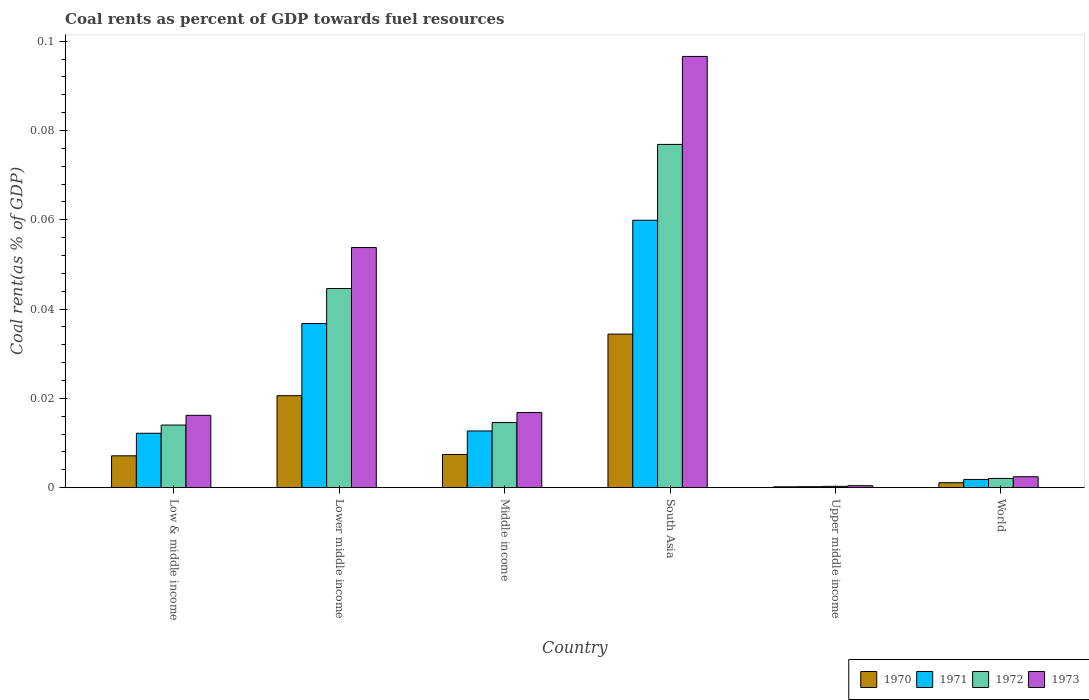How many groups of bars are there?
Give a very brief answer. 6. Are the number of bars per tick equal to the number of legend labels?
Your response must be concise. Yes. In how many cases, is the number of bars for a given country not equal to the number of legend labels?
Offer a terse response. 0. What is the coal rent in 1972 in Lower middle income?
Keep it short and to the point. 0.04. Across all countries, what is the maximum coal rent in 1971?
Your answer should be very brief. 0.06. Across all countries, what is the minimum coal rent in 1970?
Provide a succinct answer. 0. In which country was the coal rent in 1970 maximum?
Your answer should be compact. South Asia. In which country was the coal rent in 1970 minimum?
Your response must be concise. Upper middle income. What is the total coal rent in 1971 in the graph?
Provide a short and direct response. 0.12. What is the difference between the coal rent in 1971 in Low & middle income and that in Lower middle income?
Give a very brief answer. -0.02. What is the difference between the coal rent in 1971 in Upper middle income and the coal rent in 1972 in Middle income?
Offer a terse response. -0.01. What is the average coal rent in 1971 per country?
Provide a short and direct response. 0.02. What is the difference between the coal rent of/in 1972 and coal rent of/in 1970 in World?
Your answer should be very brief. 0. In how many countries, is the coal rent in 1970 greater than 0.028 %?
Keep it short and to the point. 1. What is the ratio of the coal rent in 1970 in Middle income to that in World?
Your answer should be very brief. 6.74. Is the difference between the coal rent in 1972 in South Asia and Upper middle income greater than the difference between the coal rent in 1970 in South Asia and Upper middle income?
Provide a short and direct response. Yes. What is the difference between the highest and the second highest coal rent in 1971?
Your answer should be compact. 0.05. What is the difference between the highest and the lowest coal rent in 1970?
Your answer should be very brief. 0.03. Is it the case that in every country, the sum of the coal rent in 1973 and coal rent in 1972 is greater than the sum of coal rent in 1970 and coal rent in 1971?
Make the answer very short. No. Are all the bars in the graph horizontal?
Offer a very short reply. No. How many countries are there in the graph?
Keep it short and to the point. 6. Are the values on the major ticks of Y-axis written in scientific E-notation?
Provide a succinct answer. No. Does the graph contain any zero values?
Your answer should be compact. No. Does the graph contain grids?
Ensure brevity in your answer.  No. Where does the legend appear in the graph?
Your answer should be very brief. Bottom right. How many legend labels are there?
Make the answer very short. 4. What is the title of the graph?
Your answer should be very brief. Coal rents as percent of GDP towards fuel resources. What is the label or title of the Y-axis?
Provide a short and direct response. Coal rent(as % of GDP). What is the Coal rent(as % of GDP) in 1970 in Low & middle income?
Give a very brief answer. 0.01. What is the Coal rent(as % of GDP) in 1971 in Low & middle income?
Your answer should be very brief. 0.01. What is the Coal rent(as % of GDP) in 1972 in Low & middle income?
Your answer should be compact. 0.01. What is the Coal rent(as % of GDP) of 1973 in Low & middle income?
Make the answer very short. 0.02. What is the Coal rent(as % of GDP) of 1970 in Lower middle income?
Provide a short and direct response. 0.02. What is the Coal rent(as % of GDP) in 1971 in Lower middle income?
Provide a short and direct response. 0.04. What is the Coal rent(as % of GDP) in 1972 in Lower middle income?
Your response must be concise. 0.04. What is the Coal rent(as % of GDP) in 1973 in Lower middle income?
Your response must be concise. 0.05. What is the Coal rent(as % of GDP) of 1970 in Middle income?
Keep it short and to the point. 0.01. What is the Coal rent(as % of GDP) of 1971 in Middle income?
Provide a succinct answer. 0.01. What is the Coal rent(as % of GDP) of 1972 in Middle income?
Provide a short and direct response. 0.01. What is the Coal rent(as % of GDP) in 1973 in Middle income?
Your answer should be compact. 0.02. What is the Coal rent(as % of GDP) in 1970 in South Asia?
Your response must be concise. 0.03. What is the Coal rent(as % of GDP) of 1971 in South Asia?
Your response must be concise. 0.06. What is the Coal rent(as % of GDP) in 1972 in South Asia?
Keep it short and to the point. 0.08. What is the Coal rent(as % of GDP) of 1973 in South Asia?
Offer a terse response. 0.1. What is the Coal rent(as % of GDP) in 1970 in Upper middle income?
Provide a short and direct response. 0. What is the Coal rent(as % of GDP) in 1971 in Upper middle income?
Keep it short and to the point. 0. What is the Coal rent(as % of GDP) in 1972 in Upper middle income?
Offer a very short reply. 0. What is the Coal rent(as % of GDP) in 1973 in Upper middle income?
Provide a succinct answer. 0. What is the Coal rent(as % of GDP) of 1970 in World?
Offer a very short reply. 0. What is the Coal rent(as % of GDP) of 1971 in World?
Your response must be concise. 0. What is the Coal rent(as % of GDP) of 1972 in World?
Make the answer very short. 0. What is the Coal rent(as % of GDP) of 1973 in World?
Your response must be concise. 0. Across all countries, what is the maximum Coal rent(as % of GDP) of 1970?
Keep it short and to the point. 0.03. Across all countries, what is the maximum Coal rent(as % of GDP) in 1971?
Provide a succinct answer. 0.06. Across all countries, what is the maximum Coal rent(as % of GDP) in 1972?
Provide a succinct answer. 0.08. Across all countries, what is the maximum Coal rent(as % of GDP) of 1973?
Your answer should be very brief. 0.1. Across all countries, what is the minimum Coal rent(as % of GDP) in 1970?
Provide a short and direct response. 0. Across all countries, what is the minimum Coal rent(as % of GDP) in 1971?
Ensure brevity in your answer.  0. Across all countries, what is the minimum Coal rent(as % of GDP) of 1972?
Your response must be concise. 0. Across all countries, what is the minimum Coal rent(as % of GDP) of 1973?
Keep it short and to the point. 0. What is the total Coal rent(as % of GDP) of 1970 in the graph?
Provide a short and direct response. 0.07. What is the total Coal rent(as % of GDP) of 1971 in the graph?
Make the answer very short. 0.12. What is the total Coal rent(as % of GDP) of 1972 in the graph?
Offer a very short reply. 0.15. What is the total Coal rent(as % of GDP) of 1973 in the graph?
Provide a succinct answer. 0.19. What is the difference between the Coal rent(as % of GDP) of 1970 in Low & middle income and that in Lower middle income?
Ensure brevity in your answer.  -0.01. What is the difference between the Coal rent(as % of GDP) of 1971 in Low & middle income and that in Lower middle income?
Your answer should be compact. -0.02. What is the difference between the Coal rent(as % of GDP) in 1972 in Low & middle income and that in Lower middle income?
Make the answer very short. -0.03. What is the difference between the Coal rent(as % of GDP) in 1973 in Low & middle income and that in Lower middle income?
Provide a succinct answer. -0.04. What is the difference between the Coal rent(as % of GDP) of 1970 in Low & middle income and that in Middle income?
Offer a very short reply. -0. What is the difference between the Coal rent(as % of GDP) of 1971 in Low & middle income and that in Middle income?
Your response must be concise. -0. What is the difference between the Coal rent(as % of GDP) of 1972 in Low & middle income and that in Middle income?
Offer a very short reply. -0. What is the difference between the Coal rent(as % of GDP) in 1973 in Low & middle income and that in Middle income?
Provide a short and direct response. -0. What is the difference between the Coal rent(as % of GDP) of 1970 in Low & middle income and that in South Asia?
Provide a succinct answer. -0.03. What is the difference between the Coal rent(as % of GDP) in 1971 in Low & middle income and that in South Asia?
Ensure brevity in your answer.  -0.05. What is the difference between the Coal rent(as % of GDP) in 1972 in Low & middle income and that in South Asia?
Keep it short and to the point. -0.06. What is the difference between the Coal rent(as % of GDP) of 1973 in Low & middle income and that in South Asia?
Provide a short and direct response. -0.08. What is the difference between the Coal rent(as % of GDP) of 1970 in Low & middle income and that in Upper middle income?
Provide a succinct answer. 0.01. What is the difference between the Coal rent(as % of GDP) in 1971 in Low & middle income and that in Upper middle income?
Provide a short and direct response. 0.01. What is the difference between the Coal rent(as % of GDP) of 1972 in Low & middle income and that in Upper middle income?
Provide a succinct answer. 0.01. What is the difference between the Coal rent(as % of GDP) in 1973 in Low & middle income and that in Upper middle income?
Your response must be concise. 0.02. What is the difference between the Coal rent(as % of GDP) in 1970 in Low & middle income and that in World?
Make the answer very short. 0.01. What is the difference between the Coal rent(as % of GDP) of 1971 in Low & middle income and that in World?
Make the answer very short. 0.01. What is the difference between the Coal rent(as % of GDP) of 1972 in Low & middle income and that in World?
Make the answer very short. 0.01. What is the difference between the Coal rent(as % of GDP) in 1973 in Low & middle income and that in World?
Make the answer very short. 0.01. What is the difference between the Coal rent(as % of GDP) of 1970 in Lower middle income and that in Middle income?
Keep it short and to the point. 0.01. What is the difference between the Coal rent(as % of GDP) of 1971 in Lower middle income and that in Middle income?
Provide a short and direct response. 0.02. What is the difference between the Coal rent(as % of GDP) in 1972 in Lower middle income and that in Middle income?
Keep it short and to the point. 0.03. What is the difference between the Coal rent(as % of GDP) in 1973 in Lower middle income and that in Middle income?
Your response must be concise. 0.04. What is the difference between the Coal rent(as % of GDP) in 1970 in Lower middle income and that in South Asia?
Offer a terse response. -0.01. What is the difference between the Coal rent(as % of GDP) of 1971 in Lower middle income and that in South Asia?
Ensure brevity in your answer.  -0.02. What is the difference between the Coal rent(as % of GDP) in 1972 in Lower middle income and that in South Asia?
Keep it short and to the point. -0.03. What is the difference between the Coal rent(as % of GDP) of 1973 in Lower middle income and that in South Asia?
Provide a short and direct response. -0.04. What is the difference between the Coal rent(as % of GDP) of 1970 in Lower middle income and that in Upper middle income?
Provide a succinct answer. 0.02. What is the difference between the Coal rent(as % of GDP) of 1971 in Lower middle income and that in Upper middle income?
Your response must be concise. 0.04. What is the difference between the Coal rent(as % of GDP) in 1972 in Lower middle income and that in Upper middle income?
Provide a short and direct response. 0.04. What is the difference between the Coal rent(as % of GDP) of 1973 in Lower middle income and that in Upper middle income?
Offer a terse response. 0.05. What is the difference between the Coal rent(as % of GDP) of 1970 in Lower middle income and that in World?
Provide a succinct answer. 0.02. What is the difference between the Coal rent(as % of GDP) in 1971 in Lower middle income and that in World?
Provide a short and direct response. 0.03. What is the difference between the Coal rent(as % of GDP) of 1972 in Lower middle income and that in World?
Your answer should be compact. 0.04. What is the difference between the Coal rent(as % of GDP) of 1973 in Lower middle income and that in World?
Provide a short and direct response. 0.05. What is the difference between the Coal rent(as % of GDP) in 1970 in Middle income and that in South Asia?
Offer a very short reply. -0.03. What is the difference between the Coal rent(as % of GDP) in 1971 in Middle income and that in South Asia?
Keep it short and to the point. -0.05. What is the difference between the Coal rent(as % of GDP) of 1972 in Middle income and that in South Asia?
Provide a short and direct response. -0.06. What is the difference between the Coal rent(as % of GDP) in 1973 in Middle income and that in South Asia?
Make the answer very short. -0.08. What is the difference between the Coal rent(as % of GDP) of 1970 in Middle income and that in Upper middle income?
Make the answer very short. 0.01. What is the difference between the Coal rent(as % of GDP) of 1971 in Middle income and that in Upper middle income?
Give a very brief answer. 0.01. What is the difference between the Coal rent(as % of GDP) of 1972 in Middle income and that in Upper middle income?
Keep it short and to the point. 0.01. What is the difference between the Coal rent(as % of GDP) of 1973 in Middle income and that in Upper middle income?
Offer a terse response. 0.02. What is the difference between the Coal rent(as % of GDP) of 1970 in Middle income and that in World?
Give a very brief answer. 0.01. What is the difference between the Coal rent(as % of GDP) in 1971 in Middle income and that in World?
Make the answer very short. 0.01. What is the difference between the Coal rent(as % of GDP) of 1972 in Middle income and that in World?
Provide a succinct answer. 0.01. What is the difference between the Coal rent(as % of GDP) in 1973 in Middle income and that in World?
Your answer should be compact. 0.01. What is the difference between the Coal rent(as % of GDP) in 1970 in South Asia and that in Upper middle income?
Your answer should be compact. 0.03. What is the difference between the Coal rent(as % of GDP) of 1971 in South Asia and that in Upper middle income?
Keep it short and to the point. 0.06. What is the difference between the Coal rent(as % of GDP) of 1972 in South Asia and that in Upper middle income?
Your answer should be compact. 0.08. What is the difference between the Coal rent(as % of GDP) of 1973 in South Asia and that in Upper middle income?
Provide a succinct answer. 0.1. What is the difference between the Coal rent(as % of GDP) in 1971 in South Asia and that in World?
Make the answer very short. 0.06. What is the difference between the Coal rent(as % of GDP) of 1972 in South Asia and that in World?
Keep it short and to the point. 0.07. What is the difference between the Coal rent(as % of GDP) of 1973 in South Asia and that in World?
Keep it short and to the point. 0.09. What is the difference between the Coal rent(as % of GDP) in 1970 in Upper middle income and that in World?
Offer a terse response. -0. What is the difference between the Coal rent(as % of GDP) of 1971 in Upper middle income and that in World?
Provide a short and direct response. -0. What is the difference between the Coal rent(as % of GDP) in 1972 in Upper middle income and that in World?
Keep it short and to the point. -0. What is the difference between the Coal rent(as % of GDP) of 1973 in Upper middle income and that in World?
Keep it short and to the point. -0. What is the difference between the Coal rent(as % of GDP) in 1970 in Low & middle income and the Coal rent(as % of GDP) in 1971 in Lower middle income?
Keep it short and to the point. -0.03. What is the difference between the Coal rent(as % of GDP) of 1970 in Low & middle income and the Coal rent(as % of GDP) of 1972 in Lower middle income?
Your answer should be very brief. -0.04. What is the difference between the Coal rent(as % of GDP) in 1970 in Low & middle income and the Coal rent(as % of GDP) in 1973 in Lower middle income?
Give a very brief answer. -0.05. What is the difference between the Coal rent(as % of GDP) of 1971 in Low & middle income and the Coal rent(as % of GDP) of 1972 in Lower middle income?
Give a very brief answer. -0.03. What is the difference between the Coal rent(as % of GDP) in 1971 in Low & middle income and the Coal rent(as % of GDP) in 1973 in Lower middle income?
Your response must be concise. -0.04. What is the difference between the Coal rent(as % of GDP) of 1972 in Low & middle income and the Coal rent(as % of GDP) of 1973 in Lower middle income?
Make the answer very short. -0.04. What is the difference between the Coal rent(as % of GDP) in 1970 in Low & middle income and the Coal rent(as % of GDP) in 1971 in Middle income?
Your response must be concise. -0.01. What is the difference between the Coal rent(as % of GDP) in 1970 in Low & middle income and the Coal rent(as % of GDP) in 1972 in Middle income?
Your response must be concise. -0.01. What is the difference between the Coal rent(as % of GDP) of 1970 in Low & middle income and the Coal rent(as % of GDP) of 1973 in Middle income?
Your response must be concise. -0.01. What is the difference between the Coal rent(as % of GDP) in 1971 in Low & middle income and the Coal rent(as % of GDP) in 1972 in Middle income?
Your answer should be compact. -0. What is the difference between the Coal rent(as % of GDP) of 1971 in Low & middle income and the Coal rent(as % of GDP) of 1973 in Middle income?
Offer a terse response. -0. What is the difference between the Coal rent(as % of GDP) of 1972 in Low & middle income and the Coal rent(as % of GDP) of 1973 in Middle income?
Provide a short and direct response. -0. What is the difference between the Coal rent(as % of GDP) in 1970 in Low & middle income and the Coal rent(as % of GDP) in 1971 in South Asia?
Provide a short and direct response. -0.05. What is the difference between the Coal rent(as % of GDP) of 1970 in Low & middle income and the Coal rent(as % of GDP) of 1972 in South Asia?
Offer a terse response. -0.07. What is the difference between the Coal rent(as % of GDP) in 1970 in Low & middle income and the Coal rent(as % of GDP) in 1973 in South Asia?
Provide a short and direct response. -0.09. What is the difference between the Coal rent(as % of GDP) in 1971 in Low & middle income and the Coal rent(as % of GDP) in 1972 in South Asia?
Make the answer very short. -0.06. What is the difference between the Coal rent(as % of GDP) of 1971 in Low & middle income and the Coal rent(as % of GDP) of 1973 in South Asia?
Your answer should be very brief. -0.08. What is the difference between the Coal rent(as % of GDP) of 1972 in Low & middle income and the Coal rent(as % of GDP) of 1973 in South Asia?
Your answer should be compact. -0.08. What is the difference between the Coal rent(as % of GDP) of 1970 in Low & middle income and the Coal rent(as % of GDP) of 1971 in Upper middle income?
Keep it short and to the point. 0.01. What is the difference between the Coal rent(as % of GDP) in 1970 in Low & middle income and the Coal rent(as % of GDP) in 1972 in Upper middle income?
Offer a very short reply. 0.01. What is the difference between the Coal rent(as % of GDP) in 1970 in Low & middle income and the Coal rent(as % of GDP) in 1973 in Upper middle income?
Offer a terse response. 0.01. What is the difference between the Coal rent(as % of GDP) in 1971 in Low & middle income and the Coal rent(as % of GDP) in 1972 in Upper middle income?
Provide a short and direct response. 0.01. What is the difference between the Coal rent(as % of GDP) in 1971 in Low & middle income and the Coal rent(as % of GDP) in 1973 in Upper middle income?
Offer a terse response. 0.01. What is the difference between the Coal rent(as % of GDP) in 1972 in Low & middle income and the Coal rent(as % of GDP) in 1973 in Upper middle income?
Your response must be concise. 0.01. What is the difference between the Coal rent(as % of GDP) of 1970 in Low & middle income and the Coal rent(as % of GDP) of 1971 in World?
Offer a very short reply. 0.01. What is the difference between the Coal rent(as % of GDP) in 1970 in Low & middle income and the Coal rent(as % of GDP) in 1972 in World?
Your response must be concise. 0.01. What is the difference between the Coal rent(as % of GDP) in 1970 in Low & middle income and the Coal rent(as % of GDP) in 1973 in World?
Provide a short and direct response. 0. What is the difference between the Coal rent(as % of GDP) of 1971 in Low & middle income and the Coal rent(as % of GDP) of 1972 in World?
Your answer should be compact. 0.01. What is the difference between the Coal rent(as % of GDP) in 1971 in Low & middle income and the Coal rent(as % of GDP) in 1973 in World?
Give a very brief answer. 0.01. What is the difference between the Coal rent(as % of GDP) of 1972 in Low & middle income and the Coal rent(as % of GDP) of 1973 in World?
Offer a terse response. 0.01. What is the difference between the Coal rent(as % of GDP) in 1970 in Lower middle income and the Coal rent(as % of GDP) in 1971 in Middle income?
Your answer should be very brief. 0.01. What is the difference between the Coal rent(as % of GDP) of 1970 in Lower middle income and the Coal rent(as % of GDP) of 1972 in Middle income?
Offer a terse response. 0.01. What is the difference between the Coal rent(as % of GDP) in 1970 in Lower middle income and the Coal rent(as % of GDP) in 1973 in Middle income?
Keep it short and to the point. 0. What is the difference between the Coal rent(as % of GDP) in 1971 in Lower middle income and the Coal rent(as % of GDP) in 1972 in Middle income?
Offer a very short reply. 0.02. What is the difference between the Coal rent(as % of GDP) of 1971 in Lower middle income and the Coal rent(as % of GDP) of 1973 in Middle income?
Provide a succinct answer. 0.02. What is the difference between the Coal rent(as % of GDP) in 1972 in Lower middle income and the Coal rent(as % of GDP) in 1973 in Middle income?
Ensure brevity in your answer.  0.03. What is the difference between the Coal rent(as % of GDP) of 1970 in Lower middle income and the Coal rent(as % of GDP) of 1971 in South Asia?
Make the answer very short. -0.04. What is the difference between the Coal rent(as % of GDP) in 1970 in Lower middle income and the Coal rent(as % of GDP) in 1972 in South Asia?
Provide a short and direct response. -0.06. What is the difference between the Coal rent(as % of GDP) of 1970 in Lower middle income and the Coal rent(as % of GDP) of 1973 in South Asia?
Your answer should be very brief. -0.08. What is the difference between the Coal rent(as % of GDP) of 1971 in Lower middle income and the Coal rent(as % of GDP) of 1972 in South Asia?
Provide a succinct answer. -0.04. What is the difference between the Coal rent(as % of GDP) of 1971 in Lower middle income and the Coal rent(as % of GDP) of 1973 in South Asia?
Ensure brevity in your answer.  -0.06. What is the difference between the Coal rent(as % of GDP) of 1972 in Lower middle income and the Coal rent(as % of GDP) of 1973 in South Asia?
Offer a very short reply. -0.05. What is the difference between the Coal rent(as % of GDP) of 1970 in Lower middle income and the Coal rent(as % of GDP) of 1971 in Upper middle income?
Keep it short and to the point. 0.02. What is the difference between the Coal rent(as % of GDP) of 1970 in Lower middle income and the Coal rent(as % of GDP) of 1972 in Upper middle income?
Provide a short and direct response. 0.02. What is the difference between the Coal rent(as % of GDP) in 1970 in Lower middle income and the Coal rent(as % of GDP) in 1973 in Upper middle income?
Provide a succinct answer. 0.02. What is the difference between the Coal rent(as % of GDP) of 1971 in Lower middle income and the Coal rent(as % of GDP) of 1972 in Upper middle income?
Your answer should be compact. 0.04. What is the difference between the Coal rent(as % of GDP) in 1971 in Lower middle income and the Coal rent(as % of GDP) in 1973 in Upper middle income?
Ensure brevity in your answer.  0.04. What is the difference between the Coal rent(as % of GDP) of 1972 in Lower middle income and the Coal rent(as % of GDP) of 1973 in Upper middle income?
Ensure brevity in your answer.  0.04. What is the difference between the Coal rent(as % of GDP) of 1970 in Lower middle income and the Coal rent(as % of GDP) of 1971 in World?
Make the answer very short. 0.02. What is the difference between the Coal rent(as % of GDP) in 1970 in Lower middle income and the Coal rent(as % of GDP) in 1972 in World?
Make the answer very short. 0.02. What is the difference between the Coal rent(as % of GDP) in 1970 in Lower middle income and the Coal rent(as % of GDP) in 1973 in World?
Offer a very short reply. 0.02. What is the difference between the Coal rent(as % of GDP) in 1971 in Lower middle income and the Coal rent(as % of GDP) in 1972 in World?
Offer a terse response. 0.03. What is the difference between the Coal rent(as % of GDP) in 1971 in Lower middle income and the Coal rent(as % of GDP) in 1973 in World?
Give a very brief answer. 0.03. What is the difference between the Coal rent(as % of GDP) in 1972 in Lower middle income and the Coal rent(as % of GDP) in 1973 in World?
Keep it short and to the point. 0.04. What is the difference between the Coal rent(as % of GDP) of 1970 in Middle income and the Coal rent(as % of GDP) of 1971 in South Asia?
Offer a terse response. -0.05. What is the difference between the Coal rent(as % of GDP) in 1970 in Middle income and the Coal rent(as % of GDP) in 1972 in South Asia?
Your response must be concise. -0.07. What is the difference between the Coal rent(as % of GDP) in 1970 in Middle income and the Coal rent(as % of GDP) in 1973 in South Asia?
Your answer should be very brief. -0.09. What is the difference between the Coal rent(as % of GDP) of 1971 in Middle income and the Coal rent(as % of GDP) of 1972 in South Asia?
Your response must be concise. -0.06. What is the difference between the Coal rent(as % of GDP) of 1971 in Middle income and the Coal rent(as % of GDP) of 1973 in South Asia?
Provide a short and direct response. -0.08. What is the difference between the Coal rent(as % of GDP) of 1972 in Middle income and the Coal rent(as % of GDP) of 1973 in South Asia?
Keep it short and to the point. -0.08. What is the difference between the Coal rent(as % of GDP) in 1970 in Middle income and the Coal rent(as % of GDP) in 1971 in Upper middle income?
Offer a terse response. 0.01. What is the difference between the Coal rent(as % of GDP) of 1970 in Middle income and the Coal rent(as % of GDP) of 1972 in Upper middle income?
Provide a short and direct response. 0.01. What is the difference between the Coal rent(as % of GDP) in 1970 in Middle income and the Coal rent(as % of GDP) in 1973 in Upper middle income?
Keep it short and to the point. 0.01. What is the difference between the Coal rent(as % of GDP) of 1971 in Middle income and the Coal rent(as % of GDP) of 1972 in Upper middle income?
Your answer should be very brief. 0.01. What is the difference between the Coal rent(as % of GDP) in 1971 in Middle income and the Coal rent(as % of GDP) in 1973 in Upper middle income?
Give a very brief answer. 0.01. What is the difference between the Coal rent(as % of GDP) in 1972 in Middle income and the Coal rent(as % of GDP) in 1973 in Upper middle income?
Provide a short and direct response. 0.01. What is the difference between the Coal rent(as % of GDP) in 1970 in Middle income and the Coal rent(as % of GDP) in 1971 in World?
Make the answer very short. 0.01. What is the difference between the Coal rent(as % of GDP) of 1970 in Middle income and the Coal rent(as % of GDP) of 1972 in World?
Offer a very short reply. 0.01. What is the difference between the Coal rent(as % of GDP) of 1970 in Middle income and the Coal rent(as % of GDP) of 1973 in World?
Provide a succinct answer. 0.01. What is the difference between the Coal rent(as % of GDP) of 1971 in Middle income and the Coal rent(as % of GDP) of 1972 in World?
Your response must be concise. 0.01. What is the difference between the Coal rent(as % of GDP) in 1971 in Middle income and the Coal rent(as % of GDP) in 1973 in World?
Offer a terse response. 0.01. What is the difference between the Coal rent(as % of GDP) of 1972 in Middle income and the Coal rent(as % of GDP) of 1973 in World?
Offer a very short reply. 0.01. What is the difference between the Coal rent(as % of GDP) in 1970 in South Asia and the Coal rent(as % of GDP) in 1971 in Upper middle income?
Your answer should be very brief. 0.03. What is the difference between the Coal rent(as % of GDP) in 1970 in South Asia and the Coal rent(as % of GDP) in 1972 in Upper middle income?
Provide a short and direct response. 0.03. What is the difference between the Coal rent(as % of GDP) in 1970 in South Asia and the Coal rent(as % of GDP) in 1973 in Upper middle income?
Ensure brevity in your answer.  0.03. What is the difference between the Coal rent(as % of GDP) in 1971 in South Asia and the Coal rent(as % of GDP) in 1972 in Upper middle income?
Your answer should be compact. 0.06. What is the difference between the Coal rent(as % of GDP) of 1971 in South Asia and the Coal rent(as % of GDP) of 1973 in Upper middle income?
Your answer should be very brief. 0.06. What is the difference between the Coal rent(as % of GDP) in 1972 in South Asia and the Coal rent(as % of GDP) in 1973 in Upper middle income?
Your answer should be very brief. 0.08. What is the difference between the Coal rent(as % of GDP) in 1970 in South Asia and the Coal rent(as % of GDP) in 1971 in World?
Provide a short and direct response. 0.03. What is the difference between the Coal rent(as % of GDP) in 1970 in South Asia and the Coal rent(as % of GDP) in 1972 in World?
Your answer should be compact. 0.03. What is the difference between the Coal rent(as % of GDP) of 1970 in South Asia and the Coal rent(as % of GDP) of 1973 in World?
Provide a short and direct response. 0.03. What is the difference between the Coal rent(as % of GDP) of 1971 in South Asia and the Coal rent(as % of GDP) of 1972 in World?
Keep it short and to the point. 0.06. What is the difference between the Coal rent(as % of GDP) in 1971 in South Asia and the Coal rent(as % of GDP) in 1973 in World?
Provide a succinct answer. 0.06. What is the difference between the Coal rent(as % of GDP) of 1972 in South Asia and the Coal rent(as % of GDP) of 1973 in World?
Give a very brief answer. 0.07. What is the difference between the Coal rent(as % of GDP) of 1970 in Upper middle income and the Coal rent(as % of GDP) of 1971 in World?
Offer a terse response. -0. What is the difference between the Coal rent(as % of GDP) in 1970 in Upper middle income and the Coal rent(as % of GDP) in 1972 in World?
Keep it short and to the point. -0. What is the difference between the Coal rent(as % of GDP) of 1970 in Upper middle income and the Coal rent(as % of GDP) of 1973 in World?
Offer a terse response. -0. What is the difference between the Coal rent(as % of GDP) in 1971 in Upper middle income and the Coal rent(as % of GDP) in 1972 in World?
Your answer should be very brief. -0. What is the difference between the Coal rent(as % of GDP) of 1971 in Upper middle income and the Coal rent(as % of GDP) of 1973 in World?
Ensure brevity in your answer.  -0. What is the difference between the Coal rent(as % of GDP) in 1972 in Upper middle income and the Coal rent(as % of GDP) in 1973 in World?
Ensure brevity in your answer.  -0. What is the average Coal rent(as % of GDP) in 1970 per country?
Give a very brief answer. 0.01. What is the average Coal rent(as % of GDP) of 1971 per country?
Offer a terse response. 0.02. What is the average Coal rent(as % of GDP) of 1972 per country?
Keep it short and to the point. 0.03. What is the average Coal rent(as % of GDP) of 1973 per country?
Ensure brevity in your answer.  0.03. What is the difference between the Coal rent(as % of GDP) in 1970 and Coal rent(as % of GDP) in 1971 in Low & middle income?
Provide a short and direct response. -0.01. What is the difference between the Coal rent(as % of GDP) in 1970 and Coal rent(as % of GDP) in 1972 in Low & middle income?
Provide a short and direct response. -0.01. What is the difference between the Coal rent(as % of GDP) of 1970 and Coal rent(as % of GDP) of 1973 in Low & middle income?
Give a very brief answer. -0.01. What is the difference between the Coal rent(as % of GDP) of 1971 and Coal rent(as % of GDP) of 1972 in Low & middle income?
Make the answer very short. -0. What is the difference between the Coal rent(as % of GDP) in 1971 and Coal rent(as % of GDP) in 1973 in Low & middle income?
Provide a short and direct response. -0. What is the difference between the Coal rent(as % of GDP) in 1972 and Coal rent(as % of GDP) in 1973 in Low & middle income?
Provide a short and direct response. -0. What is the difference between the Coal rent(as % of GDP) in 1970 and Coal rent(as % of GDP) in 1971 in Lower middle income?
Your answer should be compact. -0.02. What is the difference between the Coal rent(as % of GDP) of 1970 and Coal rent(as % of GDP) of 1972 in Lower middle income?
Ensure brevity in your answer.  -0.02. What is the difference between the Coal rent(as % of GDP) in 1970 and Coal rent(as % of GDP) in 1973 in Lower middle income?
Provide a short and direct response. -0.03. What is the difference between the Coal rent(as % of GDP) in 1971 and Coal rent(as % of GDP) in 1972 in Lower middle income?
Your response must be concise. -0.01. What is the difference between the Coal rent(as % of GDP) in 1971 and Coal rent(as % of GDP) in 1973 in Lower middle income?
Your answer should be very brief. -0.02. What is the difference between the Coal rent(as % of GDP) of 1972 and Coal rent(as % of GDP) of 1973 in Lower middle income?
Your answer should be very brief. -0.01. What is the difference between the Coal rent(as % of GDP) of 1970 and Coal rent(as % of GDP) of 1971 in Middle income?
Your answer should be compact. -0.01. What is the difference between the Coal rent(as % of GDP) of 1970 and Coal rent(as % of GDP) of 1972 in Middle income?
Provide a succinct answer. -0.01. What is the difference between the Coal rent(as % of GDP) of 1970 and Coal rent(as % of GDP) of 1973 in Middle income?
Offer a very short reply. -0.01. What is the difference between the Coal rent(as % of GDP) of 1971 and Coal rent(as % of GDP) of 1972 in Middle income?
Keep it short and to the point. -0. What is the difference between the Coal rent(as % of GDP) in 1971 and Coal rent(as % of GDP) in 1973 in Middle income?
Keep it short and to the point. -0. What is the difference between the Coal rent(as % of GDP) in 1972 and Coal rent(as % of GDP) in 1973 in Middle income?
Provide a short and direct response. -0. What is the difference between the Coal rent(as % of GDP) of 1970 and Coal rent(as % of GDP) of 1971 in South Asia?
Your response must be concise. -0.03. What is the difference between the Coal rent(as % of GDP) in 1970 and Coal rent(as % of GDP) in 1972 in South Asia?
Provide a succinct answer. -0.04. What is the difference between the Coal rent(as % of GDP) in 1970 and Coal rent(as % of GDP) in 1973 in South Asia?
Keep it short and to the point. -0.06. What is the difference between the Coal rent(as % of GDP) in 1971 and Coal rent(as % of GDP) in 1972 in South Asia?
Offer a very short reply. -0.02. What is the difference between the Coal rent(as % of GDP) in 1971 and Coal rent(as % of GDP) in 1973 in South Asia?
Give a very brief answer. -0.04. What is the difference between the Coal rent(as % of GDP) of 1972 and Coal rent(as % of GDP) of 1973 in South Asia?
Your answer should be compact. -0.02. What is the difference between the Coal rent(as % of GDP) in 1970 and Coal rent(as % of GDP) in 1971 in Upper middle income?
Offer a terse response. -0. What is the difference between the Coal rent(as % of GDP) of 1970 and Coal rent(as % of GDP) of 1972 in Upper middle income?
Keep it short and to the point. -0. What is the difference between the Coal rent(as % of GDP) of 1970 and Coal rent(as % of GDP) of 1973 in Upper middle income?
Ensure brevity in your answer.  -0. What is the difference between the Coal rent(as % of GDP) in 1971 and Coal rent(as % of GDP) in 1972 in Upper middle income?
Provide a short and direct response. -0. What is the difference between the Coal rent(as % of GDP) in 1971 and Coal rent(as % of GDP) in 1973 in Upper middle income?
Ensure brevity in your answer.  -0. What is the difference between the Coal rent(as % of GDP) in 1972 and Coal rent(as % of GDP) in 1973 in Upper middle income?
Your response must be concise. -0. What is the difference between the Coal rent(as % of GDP) in 1970 and Coal rent(as % of GDP) in 1971 in World?
Ensure brevity in your answer.  -0. What is the difference between the Coal rent(as % of GDP) of 1970 and Coal rent(as % of GDP) of 1972 in World?
Make the answer very short. -0. What is the difference between the Coal rent(as % of GDP) of 1970 and Coal rent(as % of GDP) of 1973 in World?
Keep it short and to the point. -0. What is the difference between the Coal rent(as % of GDP) in 1971 and Coal rent(as % of GDP) in 1972 in World?
Keep it short and to the point. -0. What is the difference between the Coal rent(as % of GDP) of 1971 and Coal rent(as % of GDP) of 1973 in World?
Ensure brevity in your answer.  -0. What is the difference between the Coal rent(as % of GDP) of 1972 and Coal rent(as % of GDP) of 1973 in World?
Offer a very short reply. -0. What is the ratio of the Coal rent(as % of GDP) of 1970 in Low & middle income to that in Lower middle income?
Make the answer very short. 0.35. What is the ratio of the Coal rent(as % of GDP) in 1971 in Low & middle income to that in Lower middle income?
Your answer should be compact. 0.33. What is the ratio of the Coal rent(as % of GDP) of 1972 in Low & middle income to that in Lower middle income?
Provide a succinct answer. 0.31. What is the ratio of the Coal rent(as % of GDP) in 1973 in Low & middle income to that in Lower middle income?
Your answer should be very brief. 0.3. What is the ratio of the Coal rent(as % of GDP) in 1970 in Low & middle income to that in Middle income?
Keep it short and to the point. 0.96. What is the ratio of the Coal rent(as % of GDP) of 1971 in Low & middle income to that in Middle income?
Keep it short and to the point. 0.96. What is the ratio of the Coal rent(as % of GDP) of 1972 in Low & middle income to that in Middle income?
Give a very brief answer. 0.96. What is the ratio of the Coal rent(as % of GDP) of 1973 in Low & middle income to that in Middle income?
Ensure brevity in your answer.  0.96. What is the ratio of the Coal rent(as % of GDP) in 1970 in Low & middle income to that in South Asia?
Your answer should be compact. 0.21. What is the ratio of the Coal rent(as % of GDP) in 1971 in Low & middle income to that in South Asia?
Make the answer very short. 0.2. What is the ratio of the Coal rent(as % of GDP) of 1972 in Low & middle income to that in South Asia?
Make the answer very short. 0.18. What is the ratio of the Coal rent(as % of GDP) in 1973 in Low & middle income to that in South Asia?
Make the answer very short. 0.17. What is the ratio of the Coal rent(as % of GDP) in 1970 in Low & middle income to that in Upper middle income?
Ensure brevity in your answer.  38.77. What is the ratio of the Coal rent(as % of GDP) of 1971 in Low & middle income to that in Upper middle income?
Offer a terse response. 55.66. What is the ratio of the Coal rent(as % of GDP) of 1972 in Low & middle income to that in Upper middle income?
Your answer should be compact. 49.28. What is the ratio of the Coal rent(as % of GDP) in 1973 in Low & middle income to that in Upper middle income?
Provide a succinct answer. 37.59. What is the ratio of the Coal rent(as % of GDP) in 1970 in Low & middle income to that in World?
Your answer should be compact. 6.48. What is the ratio of the Coal rent(as % of GDP) of 1971 in Low & middle income to that in World?
Give a very brief answer. 6.65. What is the ratio of the Coal rent(as % of GDP) in 1972 in Low & middle income to that in World?
Ensure brevity in your answer.  6.82. What is the ratio of the Coal rent(as % of GDP) of 1973 in Low & middle income to that in World?
Ensure brevity in your answer.  6.65. What is the ratio of the Coal rent(as % of GDP) of 1970 in Lower middle income to that in Middle income?
Your answer should be very brief. 2.78. What is the ratio of the Coal rent(as % of GDP) of 1971 in Lower middle income to that in Middle income?
Offer a very short reply. 2.9. What is the ratio of the Coal rent(as % of GDP) of 1972 in Lower middle income to that in Middle income?
Offer a terse response. 3.06. What is the ratio of the Coal rent(as % of GDP) in 1973 in Lower middle income to that in Middle income?
Offer a very short reply. 3.2. What is the ratio of the Coal rent(as % of GDP) in 1970 in Lower middle income to that in South Asia?
Provide a short and direct response. 0.6. What is the ratio of the Coal rent(as % of GDP) in 1971 in Lower middle income to that in South Asia?
Ensure brevity in your answer.  0.61. What is the ratio of the Coal rent(as % of GDP) in 1972 in Lower middle income to that in South Asia?
Make the answer very short. 0.58. What is the ratio of the Coal rent(as % of GDP) in 1973 in Lower middle income to that in South Asia?
Offer a terse response. 0.56. What is the ratio of the Coal rent(as % of GDP) of 1970 in Lower middle income to that in Upper middle income?
Ensure brevity in your answer.  112.03. What is the ratio of the Coal rent(as % of GDP) in 1971 in Lower middle income to that in Upper middle income?
Your response must be concise. 167.98. What is the ratio of the Coal rent(as % of GDP) in 1972 in Lower middle income to that in Upper middle income?
Ensure brevity in your answer.  156.82. What is the ratio of the Coal rent(as % of GDP) of 1973 in Lower middle income to that in Upper middle income?
Offer a terse response. 124.82. What is the ratio of the Coal rent(as % of GDP) of 1970 in Lower middle income to that in World?
Offer a terse response. 18.71. What is the ratio of the Coal rent(as % of GDP) of 1971 in Lower middle income to that in World?
Ensure brevity in your answer.  20.06. What is the ratio of the Coal rent(as % of GDP) of 1972 in Lower middle income to that in World?
Provide a succinct answer. 21.7. What is the ratio of the Coal rent(as % of GDP) in 1973 in Lower middle income to that in World?
Make the answer very short. 22.07. What is the ratio of the Coal rent(as % of GDP) in 1970 in Middle income to that in South Asia?
Your answer should be very brief. 0.22. What is the ratio of the Coal rent(as % of GDP) in 1971 in Middle income to that in South Asia?
Give a very brief answer. 0.21. What is the ratio of the Coal rent(as % of GDP) of 1972 in Middle income to that in South Asia?
Make the answer very short. 0.19. What is the ratio of the Coal rent(as % of GDP) in 1973 in Middle income to that in South Asia?
Offer a very short reply. 0.17. What is the ratio of the Coal rent(as % of GDP) in 1970 in Middle income to that in Upper middle income?
Provide a short and direct response. 40.36. What is the ratio of the Coal rent(as % of GDP) of 1971 in Middle income to that in Upper middle income?
Offer a terse response. 58.01. What is the ratio of the Coal rent(as % of GDP) of 1972 in Middle income to that in Upper middle income?
Offer a very short reply. 51.25. What is the ratio of the Coal rent(as % of GDP) in 1973 in Middle income to that in Upper middle income?
Keep it short and to the point. 39.04. What is the ratio of the Coal rent(as % of GDP) in 1970 in Middle income to that in World?
Your answer should be very brief. 6.74. What is the ratio of the Coal rent(as % of GDP) of 1971 in Middle income to that in World?
Your answer should be compact. 6.93. What is the ratio of the Coal rent(as % of GDP) of 1972 in Middle income to that in World?
Give a very brief answer. 7.09. What is the ratio of the Coal rent(as % of GDP) in 1973 in Middle income to that in World?
Ensure brevity in your answer.  6.91. What is the ratio of the Coal rent(as % of GDP) of 1970 in South Asia to that in Upper middle income?
Give a very brief answer. 187.05. What is the ratio of the Coal rent(as % of GDP) in 1971 in South Asia to that in Upper middle income?
Provide a short and direct response. 273.74. What is the ratio of the Coal rent(as % of GDP) of 1972 in South Asia to that in Upper middle income?
Your response must be concise. 270.32. What is the ratio of the Coal rent(as % of GDP) in 1973 in South Asia to that in Upper middle income?
Provide a short and direct response. 224.18. What is the ratio of the Coal rent(as % of GDP) in 1970 in South Asia to that in World?
Keep it short and to the point. 31.24. What is the ratio of the Coal rent(as % of GDP) of 1971 in South Asia to that in World?
Provide a succinct answer. 32.69. What is the ratio of the Coal rent(as % of GDP) of 1972 in South Asia to that in World?
Your response must be concise. 37.41. What is the ratio of the Coal rent(as % of GDP) in 1973 in South Asia to that in World?
Keep it short and to the point. 39.65. What is the ratio of the Coal rent(as % of GDP) in 1970 in Upper middle income to that in World?
Offer a terse response. 0.17. What is the ratio of the Coal rent(as % of GDP) in 1971 in Upper middle income to that in World?
Give a very brief answer. 0.12. What is the ratio of the Coal rent(as % of GDP) in 1972 in Upper middle income to that in World?
Offer a terse response. 0.14. What is the ratio of the Coal rent(as % of GDP) of 1973 in Upper middle income to that in World?
Your response must be concise. 0.18. What is the difference between the highest and the second highest Coal rent(as % of GDP) of 1970?
Ensure brevity in your answer.  0.01. What is the difference between the highest and the second highest Coal rent(as % of GDP) of 1971?
Keep it short and to the point. 0.02. What is the difference between the highest and the second highest Coal rent(as % of GDP) in 1972?
Offer a terse response. 0.03. What is the difference between the highest and the second highest Coal rent(as % of GDP) of 1973?
Provide a succinct answer. 0.04. What is the difference between the highest and the lowest Coal rent(as % of GDP) in 1970?
Provide a succinct answer. 0.03. What is the difference between the highest and the lowest Coal rent(as % of GDP) in 1971?
Your answer should be compact. 0.06. What is the difference between the highest and the lowest Coal rent(as % of GDP) of 1972?
Make the answer very short. 0.08. What is the difference between the highest and the lowest Coal rent(as % of GDP) of 1973?
Make the answer very short. 0.1. 